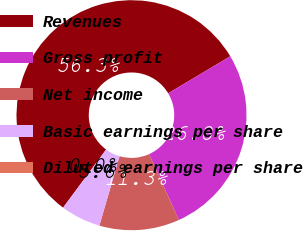Convert chart. <chart><loc_0><loc_0><loc_500><loc_500><pie_chart><fcel>Revenues<fcel>Gross profit<fcel>Net income<fcel>Basic earnings per share<fcel>Diluted earnings per share<nl><fcel>56.3%<fcel>26.81%<fcel>11.26%<fcel>5.63%<fcel>0.0%<nl></chart> 